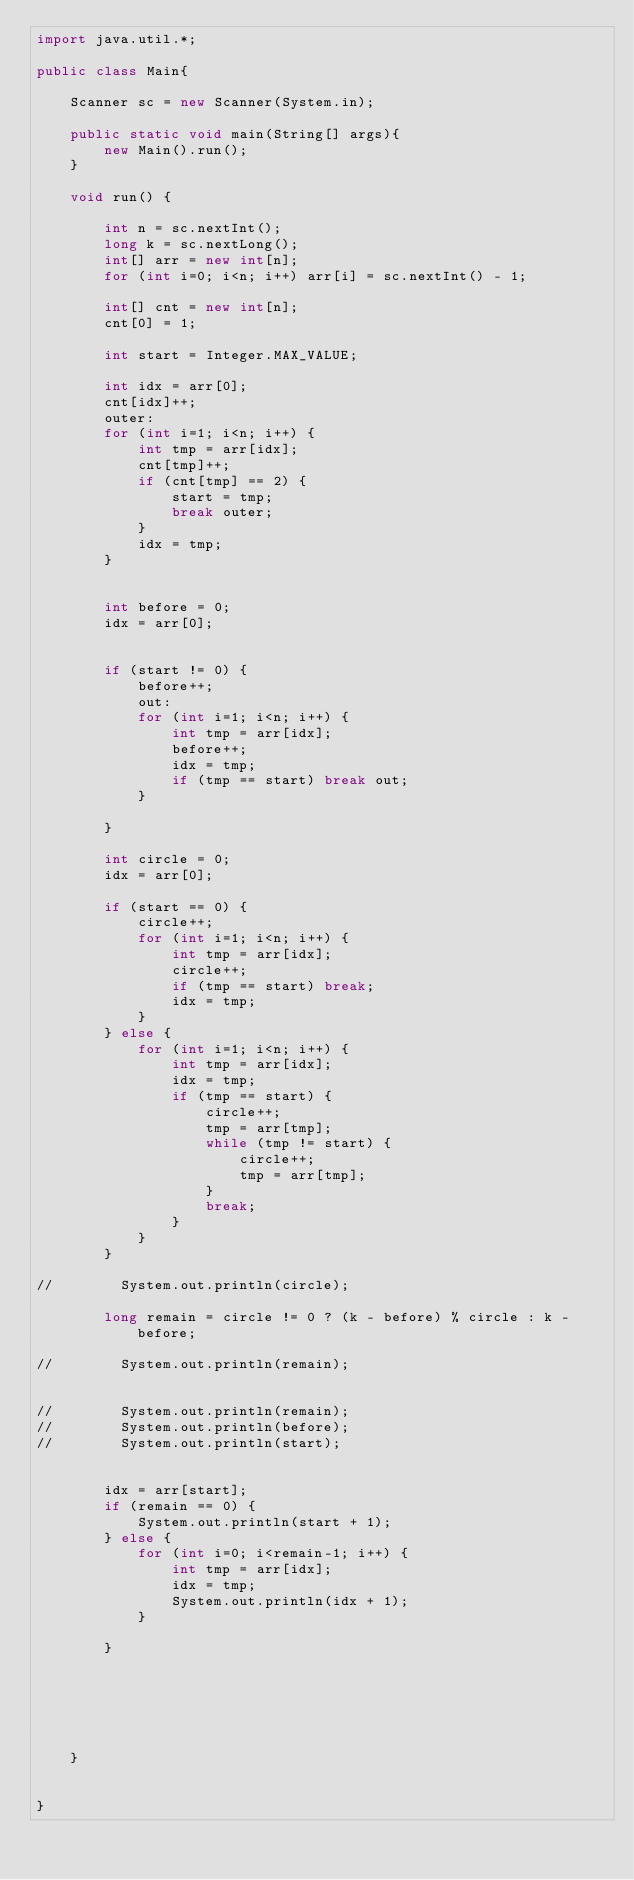Convert code to text. <code><loc_0><loc_0><loc_500><loc_500><_Java_>import java.util.*;

public class Main{

    Scanner sc = new Scanner(System.in);

    public static void main(String[] args){
        new Main().run();
    }

    void run() {

        int n = sc.nextInt();
        long k = sc.nextLong();
        int[] arr = new int[n];
        for (int i=0; i<n; i++) arr[i] = sc.nextInt() - 1;

        int[] cnt = new int[n];
        cnt[0] = 1;

        int start = Integer.MAX_VALUE;

        int idx = arr[0];
        cnt[idx]++;
        outer:
        for (int i=1; i<n; i++) {
            int tmp = arr[idx];
            cnt[tmp]++;
            if (cnt[tmp] == 2) {
                start = tmp;
                break outer;
            }
            idx = tmp;
        }


        int before = 0;
        idx = arr[0];


        if (start != 0) {
            before++;
            out:
            for (int i=1; i<n; i++) {
                int tmp = arr[idx];
                before++;
                idx = tmp;
                if (tmp == start) break out;
            }

        }

        int circle = 0;
        idx = arr[0];

        if (start == 0) {
            circle++;
            for (int i=1; i<n; i++) {
                int tmp = arr[idx];
                circle++;
                if (tmp == start) break;
                idx = tmp;
            }
        } else {
            for (int i=1; i<n; i++) {
                int tmp = arr[idx];
                idx = tmp;
                if (tmp == start) {
                    circle++;
                    tmp = arr[tmp];
                    while (tmp != start) {
                        circle++;
                        tmp = arr[tmp];
                    }
                    break;
                }
            }
        }

//        System.out.println(circle);

        long remain = circle != 0 ? (k - before) % circle : k - before;

//        System.out.println(remain);


//        System.out.println(remain);
//        System.out.println(before);
//        System.out.println(start);


        idx = arr[start];
        if (remain == 0) {
            System.out.println(start + 1);
        } else {
            for (int i=0; i<remain-1; i++) {
                int tmp = arr[idx];
                idx = tmp;
                System.out.println(idx + 1);
            }

        }






    }


}
</code> 